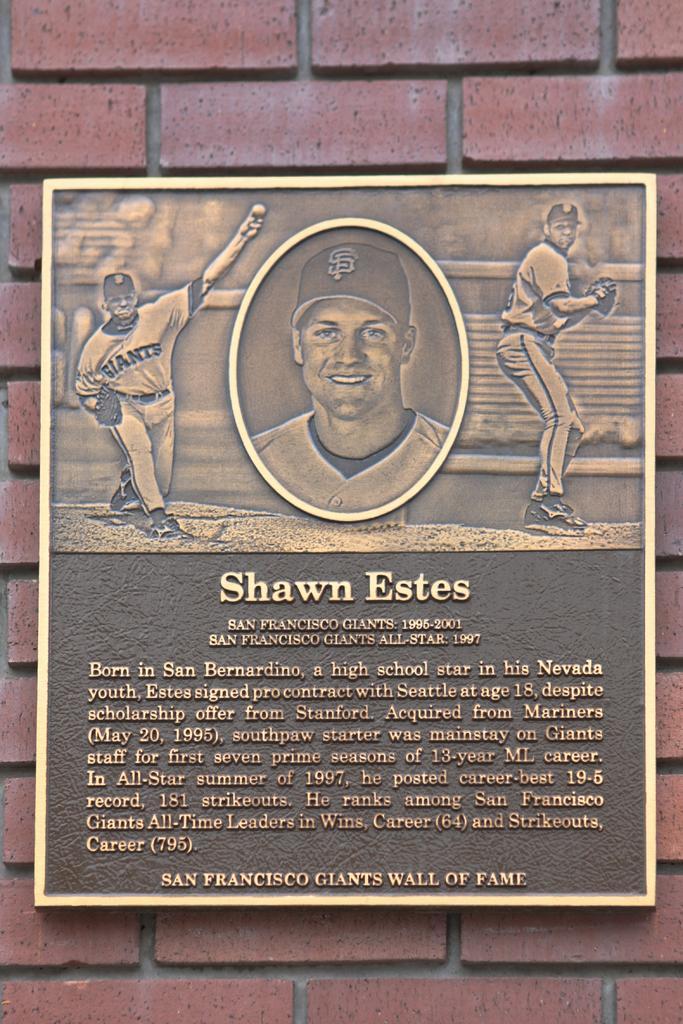How would you summarize this image in a sentence or two? In this image I can see the board to the brown color brick wall. 